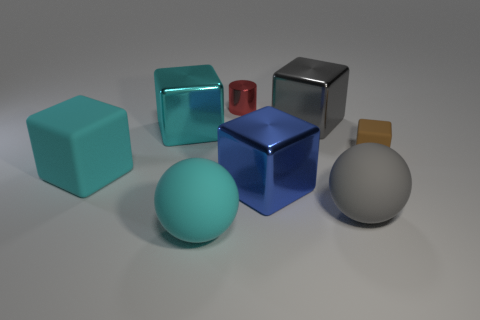Subtract all large gray blocks. How many blocks are left? 4 Subtract all cyan spheres. How many spheres are left? 1 Subtract all balls. How many objects are left? 6 Add 1 tiny purple rubber balls. How many objects exist? 9 Subtract 1 spheres. How many spheres are left? 1 Subtract 0 purple balls. How many objects are left? 8 Subtract all purple cylinders. Subtract all red blocks. How many cylinders are left? 1 Subtract all green spheres. How many cyan cubes are left? 2 Subtract all tiny blue cubes. Subtract all gray rubber things. How many objects are left? 7 Add 5 small brown blocks. How many small brown blocks are left? 6 